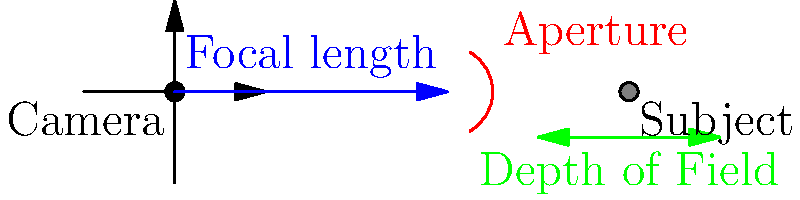In street photography, you're using a lens with a focal length of 50mm and an aperture of f/8. Your subject is 3 meters away. Calculate the depth of field, assuming a circle of confusion of 0.03mm for your camera sensor. How does this depth of field contribute to capturing candid moments on the street? To calculate the depth of field, we'll use the following steps:

1. Calculate the hyperfocal distance (H):
   $$H = \frac{f^2}{N \cdot c} + f$$
   Where f is focal length, N is f-number, and c is circle of confusion.
   $$H = \frac{50^2}{8 \cdot 0.03} + 50 = 10.42\text{ meters}$$

2. Calculate the near limit of acceptable sharpness (Dn):
   $$D_n = \frac{sH}{H+s-f}$$
   Where s is the subject distance.
   $$D_n = \frac{3 \cdot 10.42}{10.42 + 3 - 0.05} = 2.33\text{ meters}$$

3. Calculate the far limit of acceptable sharpness (Df):
   $$D_f = \frac{sH}{H-s+f}$$
   $$D_f = \frac{3 \cdot 10.42}{10.42 - 3 + 0.05} = 4.23\text{ meters}$$

4. Calculate the total depth of field:
   $$\text{DoF} = D_f - D_n = 4.23 - 2.33 = 1.90\text{ meters}$$

This depth of field contributes to capturing candid moments on the street by providing a good balance between subject sharpness and environmental context. With a DoF of 1.90 meters, you can keep your subject in focus while still having some background elements recognizable, creating a sense of place and atmosphere in your street photographs.
Answer: 1.90 meters; allows focus on subject while maintaining context 